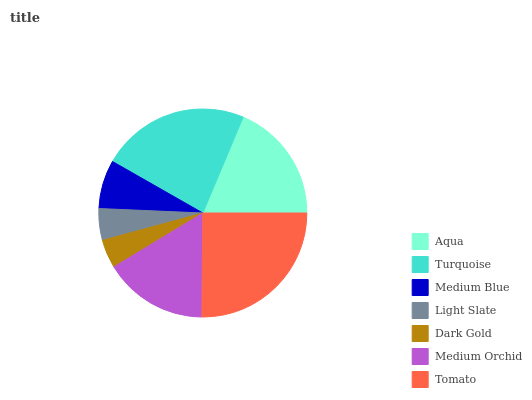Is Dark Gold the minimum?
Answer yes or no. Yes. Is Tomato the maximum?
Answer yes or no. Yes. Is Turquoise the minimum?
Answer yes or no. No. Is Turquoise the maximum?
Answer yes or no. No. Is Turquoise greater than Aqua?
Answer yes or no. Yes. Is Aqua less than Turquoise?
Answer yes or no. Yes. Is Aqua greater than Turquoise?
Answer yes or no. No. Is Turquoise less than Aqua?
Answer yes or no. No. Is Medium Orchid the high median?
Answer yes or no. Yes. Is Medium Orchid the low median?
Answer yes or no. Yes. Is Dark Gold the high median?
Answer yes or no. No. Is Aqua the low median?
Answer yes or no. No. 